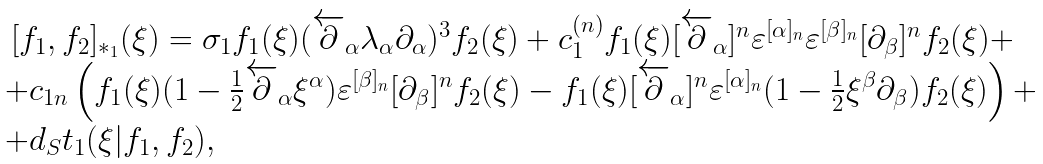Convert formula to latex. <formula><loc_0><loc_0><loc_500><loc_500>\begin{array} { l } { { \, [ f _ { 1 } , f _ { 2 } ] _ { * _ { 1 } } ( \xi ) = \sigma _ { 1 } f _ { 1 } ( \xi ) ( \overleftarrow { \partial } _ { \alpha } \lambda _ { \alpha } \partial _ { \alpha } ) ^ { 3 } f _ { 2 } ( \xi ) + c _ { 1 } ^ { ( n ) } f _ { 1 } ( \xi ) [ \overleftarrow { \partial } _ { \alpha } ] ^ { n } \varepsilon ^ { [ \alpha ] _ { n } } \varepsilon ^ { [ \beta ] _ { n } } [ \partial _ { \beta } ] ^ { n } f _ { 2 } ( \xi ) + } } \\ { { + c _ { 1 n } \left ( f _ { 1 } ( \xi ) ( 1 - { \frac { 1 } { 2 } } \overleftarrow { \partial } _ { \alpha } \xi ^ { \alpha } ) \varepsilon ^ { [ \beta ] _ { n } } [ \partial _ { \beta } ] ^ { n } f _ { 2 } ( \xi ) - f _ { 1 } ( \xi ) [ \overleftarrow { \partial } _ { \alpha } ] ^ { n } \varepsilon ^ { [ \alpha ] _ { n } } ( 1 - { \frac { 1 } { 2 } } \xi ^ { \beta } \partial _ { \beta } ) f _ { 2 } ( \xi ) \right ) + } } \\ { { + d _ { S } t _ { 1 } ( \xi | f _ { 1 } , f _ { 2 } ) , } } \end{array}</formula> 